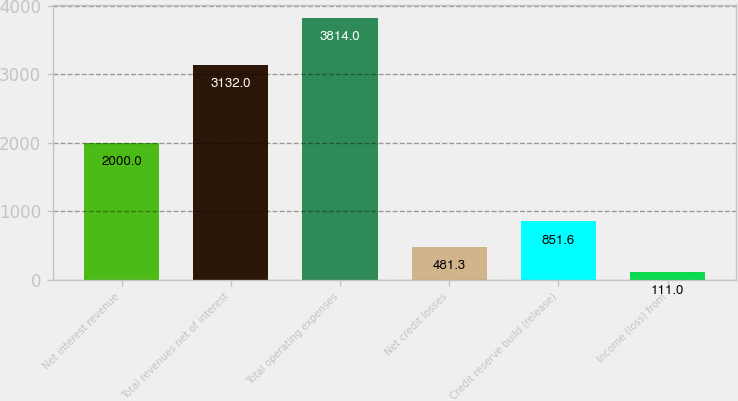Convert chart. <chart><loc_0><loc_0><loc_500><loc_500><bar_chart><fcel>Net interest revenue<fcel>Total revenues net of interest<fcel>Total operating expenses<fcel>Net credit losses<fcel>Credit reserve build (release)<fcel>Income (loss) from<nl><fcel>2000<fcel>3132<fcel>3814<fcel>481.3<fcel>851.6<fcel>111<nl></chart> 